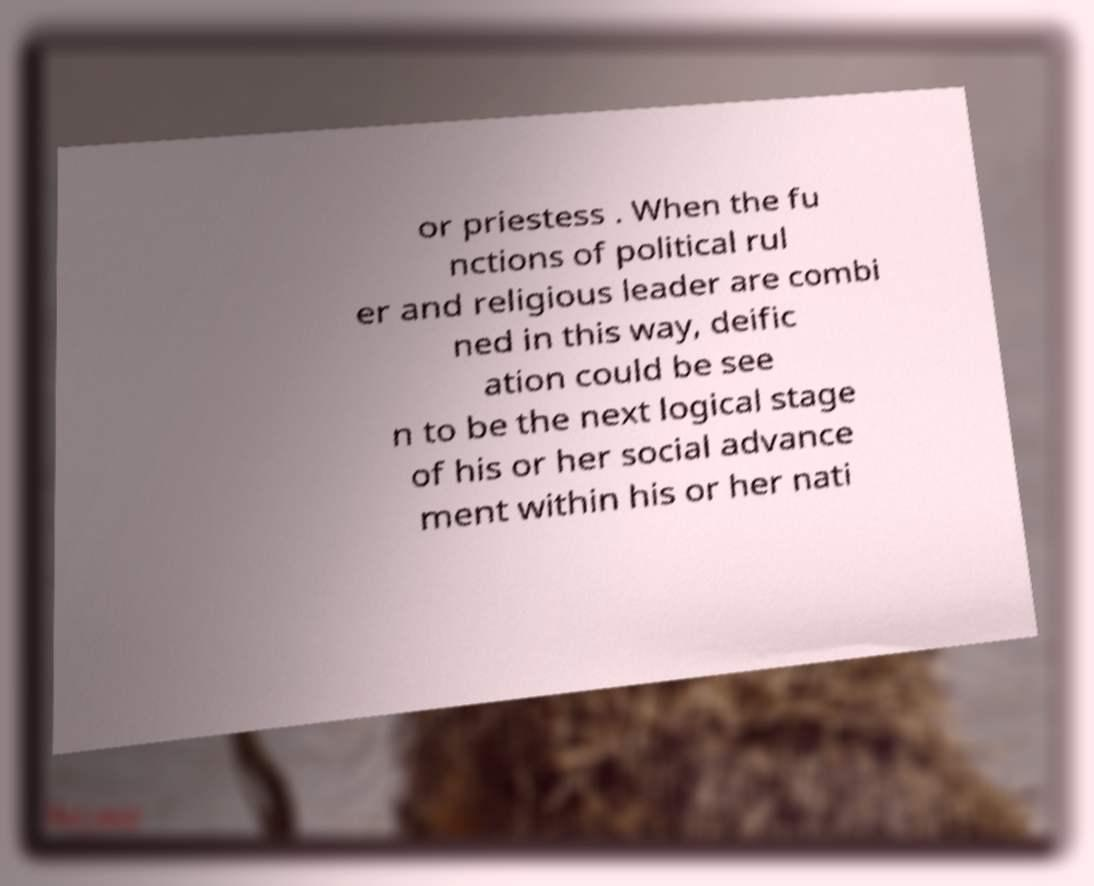Please identify and transcribe the text found in this image. or priestess . When the fu nctions of political rul er and religious leader are combi ned in this way, deific ation could be see n to be the next logical stage of his or her social advance ment within his or her nati 